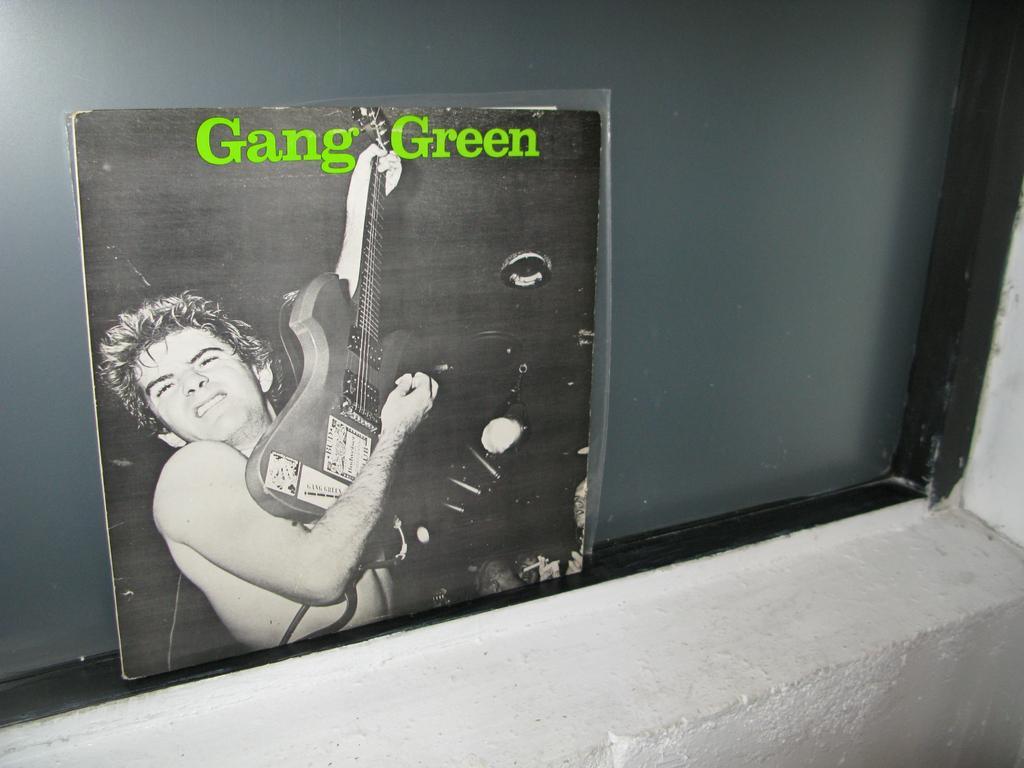Could you give a brief overview of what you see in this image? In this image we can see a window, we can see a black cover page on which a person is playing the guitar, the background is in black color, there is a white wall. 